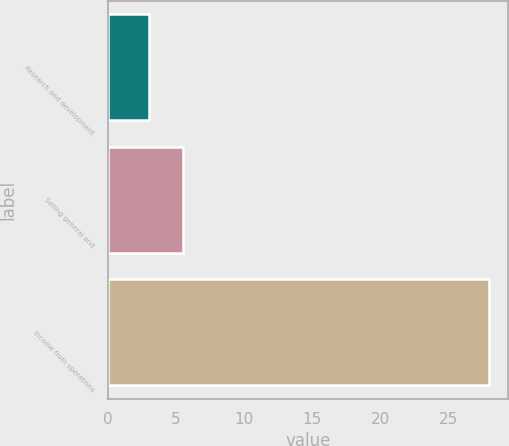Convert chart to OTSL. <chart><loc_0><loc_0><loc_500><loc_500><bar_chart><fcel>Research and development<fcel>Selling general and<fcel>Income from operations<nl><fcel>3<fcel>5.5<fcel>28<nl></chart> 